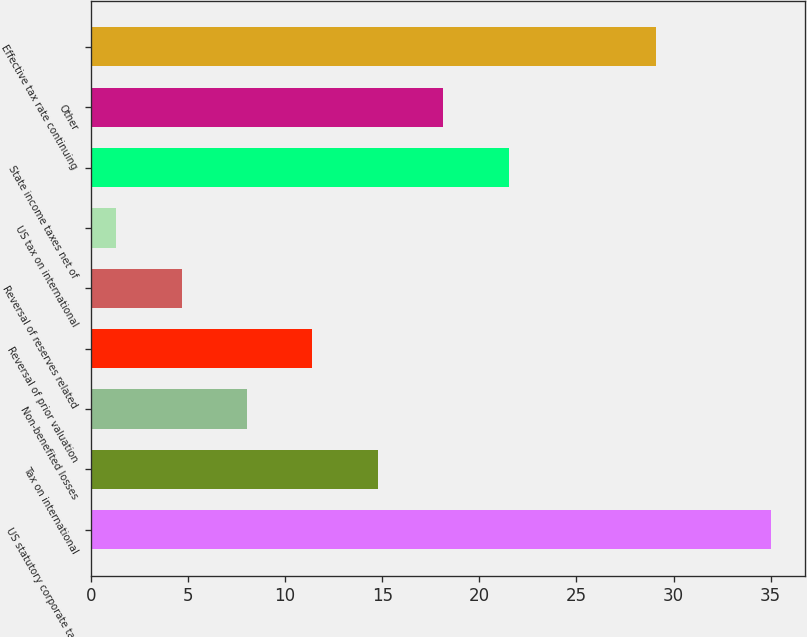<chart> <loc_0><loc_0><loc_500><loc_500><bar_chart><fcel>US statutory corporate tax<fcel>Tax on international<fcel>Non-benefited losses<fcel>Reversal of prior valuation<fcel>Reversal of reserves related<fcel>US tax on international<fcel>State income taxes net of<fcel>Other<fcel>Effective tax rate continuing<nl><fcel>35<fcel>14.78<fcel>8.04<fcel>11.41<fcel>4.67<fcel>1.3<fcel>21.52<fcel>18.15<fcel>29.1<nl></chart> 